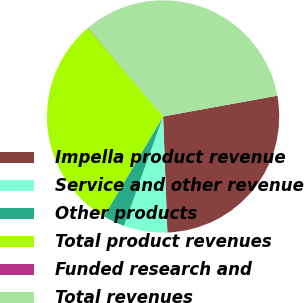Convert chart to OTSL. <chart><loc_0><loc_0><loc_500><loc_500><pie_chart><fcel>Impella product revenue<fcel>Service and other revenue<fcel>Other products<fcel>Total product revenues<fcel>Funded research and<fcel>Total revenues<nl><fcel>27.28%<fcel>6.05%<fcel>3.05%<fcel>30.28%<fcel>0.06%<fcel>33.27%<nl></chart> 